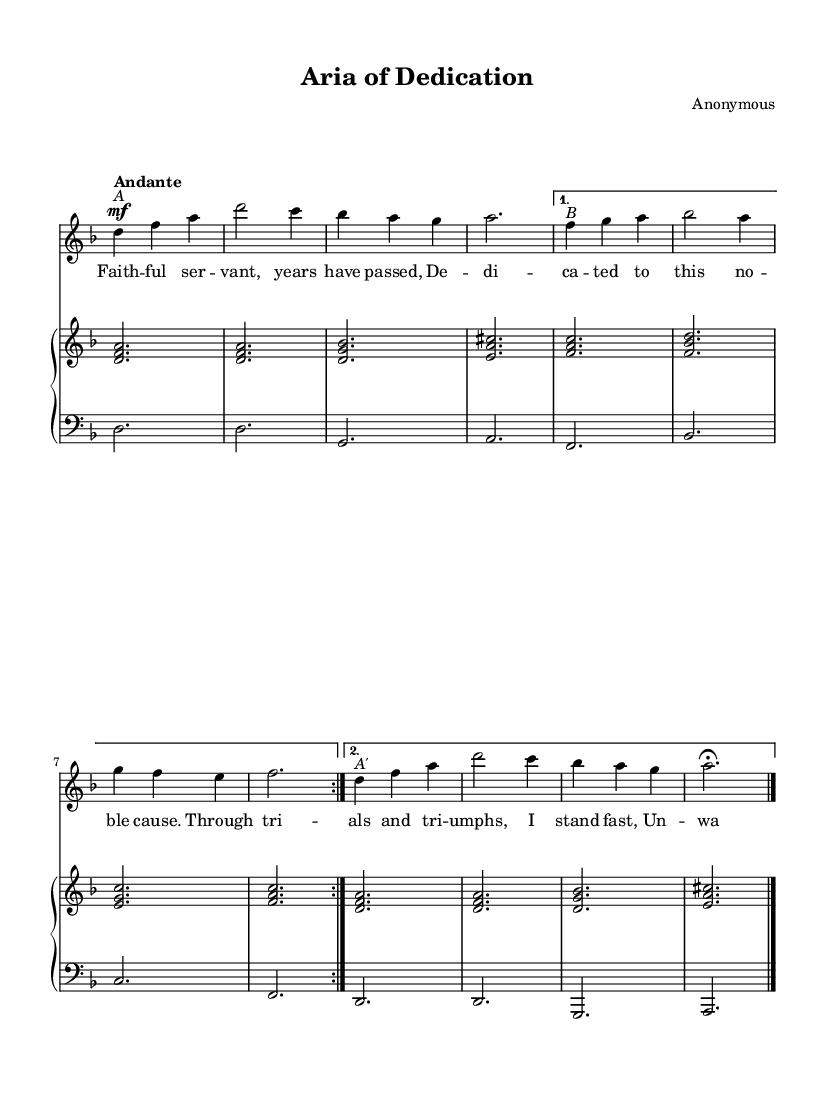What is the key signature of this music? The key signature is indicated at the beginning of the sheet music. Here, it shows a B♭ key, meaning there are two flats.
Answer: B♭ major What is the time signature of this music? The time signature is displayed in the beginning of the score as 3/4, indicating there are three beats in a measure and a quarter note receives one beat.
Answer: 3/4 What is the tempo marking? The tempo marking is provided as "Andante," which suggests a moderate walking pace for the performance of the piece.
Answer: Andante How many bars are in the A section? The A section is identified in the sheet music and consists of two repeated segments. Each segment has four bars, totalling eight bars.
Answer: 8 What is the dynamic marking for the soprano part at the beginning? The dynamic marking appears as "mf," which stands for mezzo-forte, indicating a moderately loud dynamic.
Answer: mf What is the text of the first line of the aria? The first line of the lyrics is "Faithful servant, years have passed," which can be found aligned with the first few notes of the soprano line.
Answer: Faithful servant, years have passed What is the form of the aria presented in the sheet music? The form can be deduced from the structure presented, which contains an A section followed by a contrasting B section, and a return to A, indicating a two-part form with a repeat.
Answer: A-B-A 